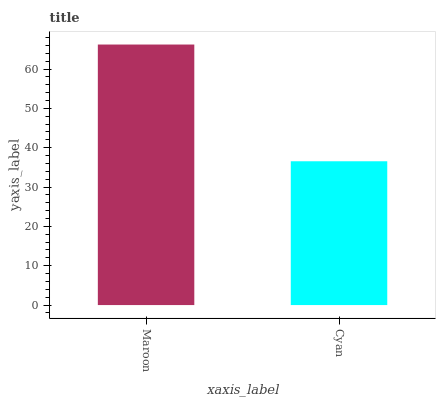Is Cyan the minimum?
Answer yes or no. Yes. Is Maroon the maximum?
Answer yes or no. Yes. Is Cyan the maximum?
Answer yes or no. No. Is Maroon greater than Cyan?
Answer yes or no. Yes. Is Cyan less than Maroon?
Answer yes or no. Yes. Is Cyan greater than Maroon?
Answer yes or no. No. Is Maroon less than Cyan?
Answer yes or no. No. Is Maroon the high median?
Answer yes or no. Yes. Is Cyan the low median?
Answer yes or no. Yes. Is Cyan the high median?
Answer yes or no. No. Is Maroon the low median?
Answer yes or no. No. 